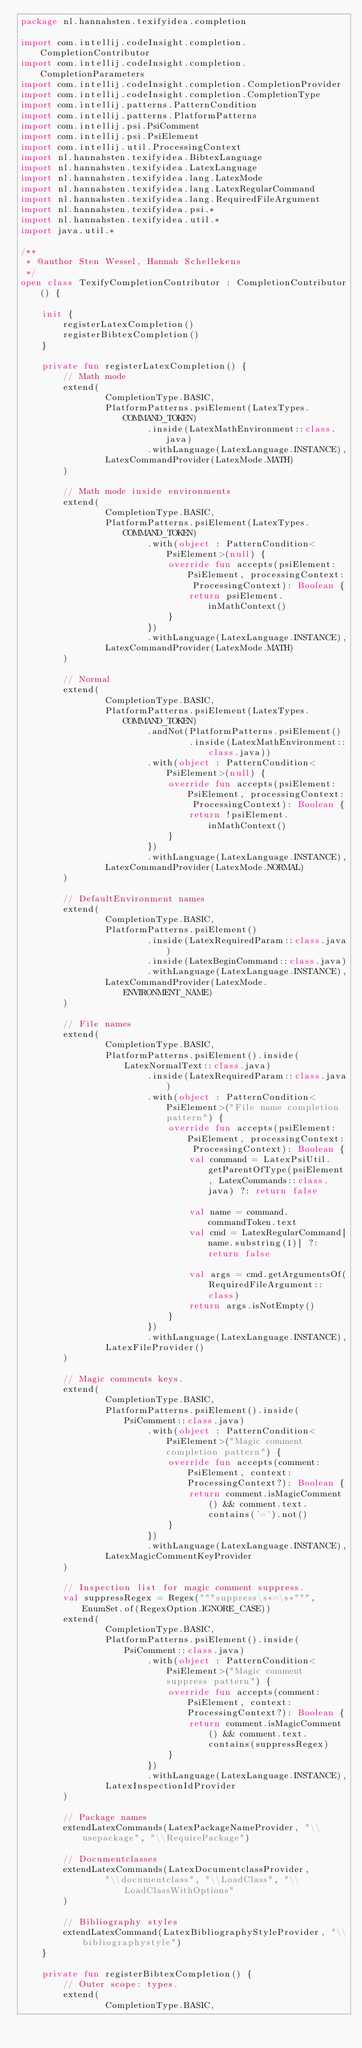<code> <loc_0><loc_0><loc_500><loc_500><_Kotlin_>package nl.hannahsten.texifyidea.completion

import com.intellij.codeInsight.completion.CompletionContributor
import com.intellij.codeInsight.completion.CompletionParameters
import com.intellij.codeInsight.completion.CompletionProvider
import com.intellij.codeInsight.completion.CompletionType
import com.intellij.patterns.PatternCondition
import com.intellij.patterns.PlatformPatterns
import com.intellij.psi.PsiComment
import com.intellij.psi.PsiElement
import com.intellij.util.ProcessingContext
import nl.hannahsten.texifyidea.BibtexLanguage
import nl.hannahsten.texifyidea.LatexLanguage
import nl.hannahsten.texifyidea.lang.LatexMode
import nl.hannahsten.texifyidea.lang.LatexRegularCommand
import nl.hannahsten.texifyidea.lang.RequiredFileArgument
import nl.hannahsten.texifyidea.psi.*
import nl.hannahsten.texifyidea.util.*
import java.util.*

/**
 * @author Sten Wessel, Hannah Schellekens
 */
open class TexifyCompletionContributor : CompletionContributor() {

    init {
        registerLatexCompletion()
        registerBibtexCompletion()
    }

    private fun registerLatexCompletion() {
        // Math mode
        extend(
                CompletionType.BASIC,
                PlatformPatterns.psiElement(LatexTypes.COMMAND_TOKEN)
                        .inside(LatexMathEnvironment::class.java)
                        .withLanguage(LatexLanguage.INSTANCE),
                LatexCommandProvider(LatexMode.MATH)
        )

        // Math mode inside environments
        extend(
                CompletionType.BASIC,
                PlatformPatterns.psiElement(LatexTypes.COMMAND_TOKEN)
                        .with(object : PatternCondition<PsiElement>(null) {
                            override fun accepts(psiElement: PsiElement, processingContext: ProcessingContext): Boolean {
                                return psiElement.inMathContext()
                            }
                        })
                        .withLanguage(LatexLanguage.INSTANCE),
                LatexCommandProvider(LatexMode.MATH)
        )

        // Normal
        extend(
                CompletionType.BASIC,
                PlatformPatterns.psiElement(LatexTypes.COMMAND_TOKEN)
                        .andNot(PlatformPatterns.psiElement()
                                .inside(LatexMathEnvironment::class.java))
                        .with(object : PatternCondition<PsiElement>(null) {
                            override fun accepts(psiElement: PsiElement, processingContext: ProcessingContext): Boolean {
                                return !psiElement.inMathContext()
                            }
                        })
                        .withLanguage(LatexLanguage.INSTANCE),
                LatexCommandProvider(LatexMode.NORMAL)
        )

        // DefaultEnvironment names
        extend(
                CompletionType.BASIC,
                PlatformPatterns.psiElement()
                        .inside(LatexRequiredParam::class.java)
                        .inside(LatexBeginCommand::class.java)
                        .withLanguage(LatexLanguage.INSTANCE),
                LatexCommandProvider(LatexMode.ENVIRONMENT_NAME)
        )

        // File names
        extend(
                CompletionType.BASIC,
                PlatformPatterns.psiElement().inside(LatexNormalText::class.java)
                        .inside(LatexRequiredParam::class.java)
                        .with(object : PatternCondition<PsiElement>("File name completion pattern") {
                            override fun accepts(psiElement: PsiElement, processingContext: ProcessingContext): Boolean {
                                val command = LatexPsiUtil.getParentOfType(psiElement, LatexCommands::class.java) ?: return false

                                val name = command.commandToken.text
                                val cmd = LatexRegularCommand[name.substring(1)] ?: return false

                                val args = cmd.getArgumentsOf(RequiredFileArgument::class)
                                return args.isNotEmpty()
                            }
                        })
                        .withLanguage(LatexLanguage.INSTANCE),
                LatexFileProvider()
        )

        // Magic comments keys.
        extend(
                CompletionType.BASIC,
                PlatformPatterns.psiElement().inside(PsiComment::class.java)
                        .with(object : PatternCondition<PsiElement>("Magic comment completion pattern") {
                            override fun accepts(comment: PsiElement, context: ProcessingContext?): Boolean {
                                return comment.isMagicComment() && comment.text.contains('=').not()
                            }
                        })
                        .withLanguage(LatexLanguage.INSTANCE),
                LatexMagicCommentKeyProvider
        )

        // Inspection list for magic comment suppress.
        val suppressRegex = Regex("""suppress\s*=\s*""", EnumSet.of(RegexOption.IGNORE_CASE))
        extend(
                CompletionType.BASIC,
                PlatformPatterns.psiElement().inside(PsiComment::class.java)
                        .with(object : PatternCondition<PsiElement>("Magic comment suppress pattern") {
                            override fun accepts(comment: PsiElement, context: ProcessingContext?): Boolean {
                                return comment.isMagicComment() && comment.text.contains(suppressRegex)
                            }
                        })
                        .withLanguage(LatexLanguage.INSTANCE),
                LatexInspectionIdProvider
        )

        // Package names
        extendLatexCommands(LatexPackageNameProvider, "\\usepackage", "\\RequirePackage")

        // Documentclasses
        extendLatexCommands(LatexDocumentclassProvider,
                "\\documentclass", "\\LoadClass", "\\LoadClassWithOptions"
        )

        // Bibliography styles
        extendLatexCommand(LatexBibliographyStyleProvider, "\\bibliographystyle")
    }

    private fun registerBibtexCompletion() {
        // Outer scope: types.
        extend(
                CompletionType.BASIC,</code> 